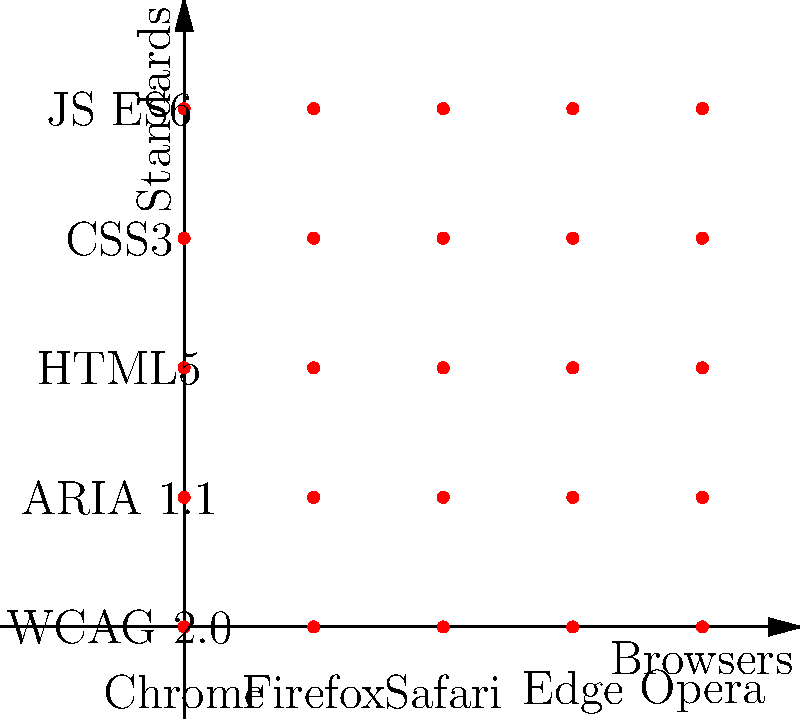Consider the group $(B, \circ)$ where $B$ represents the set of popular web browsers {Chrome, Firefox, Safari, Edge, Opera} and $\circ$ represents the operation of combining accessibility standards across browsers. Given that this group is Abelian, which property of Abelian groups is most critical for ensuring consistent web accessibility across all browsers? To answer this question, let's consider the properties of Abelian groups and how they relate to web accessibility standards across browsers:

1. Closure: For all $a, b \in B$, $a \circ b \in B$. This means that combining accessibility standards of any two browsers results in a standard that is still within the set of browsers.

2. Associativity: For all $a, b, c \in B$, $(a \circ b) \circ c = a \circ (b \circ c)$. This property ensures that the order of applying standards across multiple browsers doesn't affect the final result.

3. Identity element: There exists an $e \in B$ such that for all $a \in B$, $e \circ a = a \circ e = a$. This could represent a baseline accessibility standard that doesn't change when combined with other browser standards.

4. Inverse element: For each $a \in B$, there exists an $a^{-1} \in B$ such that $a \circ a^{-1} = a^{-1} \circ a = e$. This property might represent the ability to "undo" or "neutralize" browser-specific accessibility implementations.

5. Commutativity: For all $a, b \in B$, $a \circ b = b \circ a$. This is the defining property of Abelian groups and is crucial for web accessibility.

The commutativity property is the most critical for ensuring consistent web accessibility across all browsers. This property means that the order in which we apply accessibility standards from different browsers doesn't matter. In practical terms, it ensures that:

- Implementing accessibility features for Chrome and then Firefox will yield the same result as implementing for Firefox and then Chrome.
- Developers can focus on meeting standards without worrying about browser-specific order of implementation.
- Users get a consistent experience regardless of which browser they use.

This property aligns with the goal of creating a universally accessible web, where standards are implemented consistently across all platforms.
Answer: Commutativity 